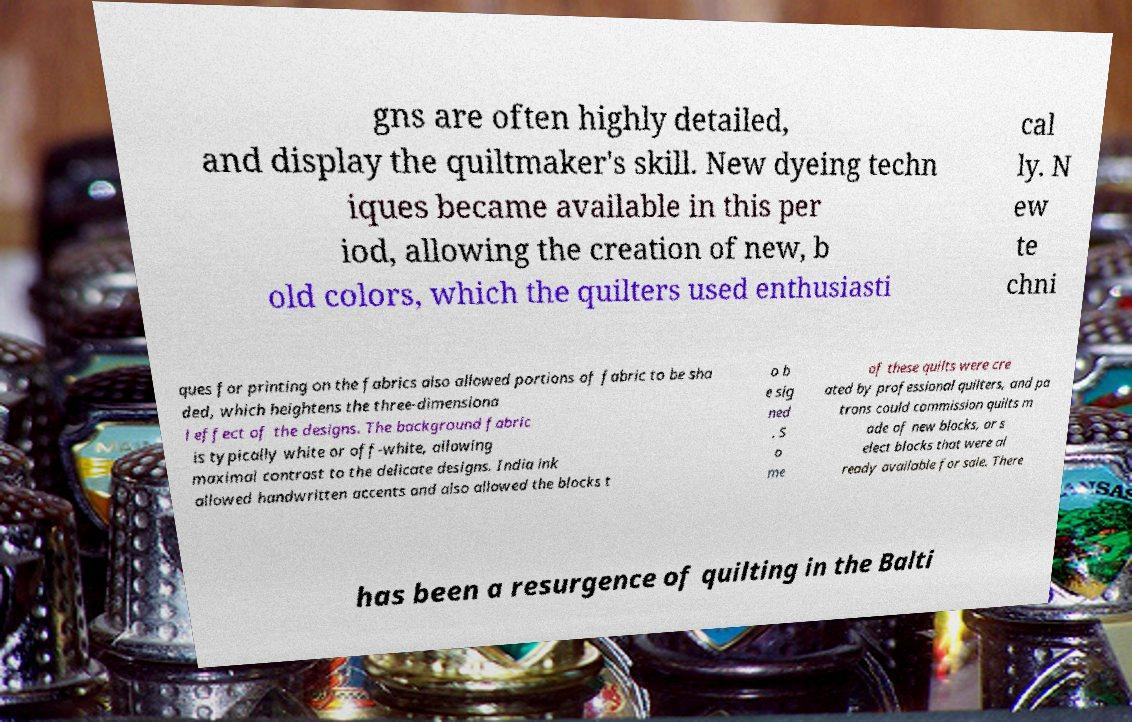I need the written content from this picture converted into text. Can you do that? gns are often highly detailed, and display the quiltmaker's skill. New dyeing techn iques became available in this per iod, allowing the creation of new, b old colors, which the quilters used enthusiasti cal ly. N ew te chni ques for printing on the fabrics also allowed portions of fabric to be sha ded, which heightens the three-dimensiona l effect of the designs. The background fabric is typically white or off-white, allowing maximal contrast to the delicate designs. India ink allowed handwritten accents and also allowed the blocks t o b e sig ned . S o me of these quilts were cre ated by professional quilters, and pa trons could commission quilts m ade of new blocks, or s elect blocks that were al ready available for sale. There has been a resurgence of quilting in the Balti 